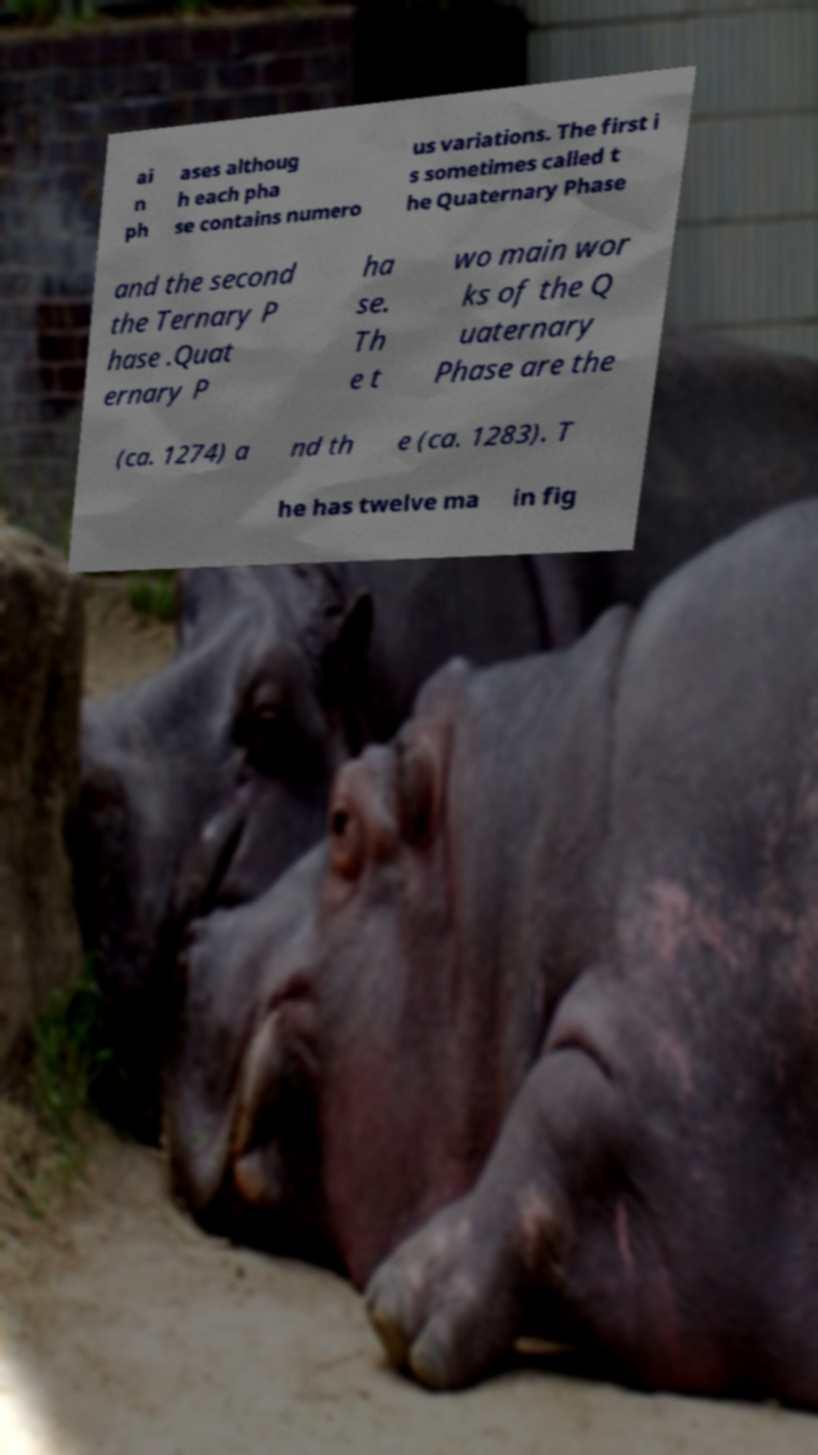There's text embedded in this image that I need extracted. Can you transcribe it verbatim? ai n ph ases althoug h each pha se contains numero us variations. The first i s sometimes called t he Quaternary Phase and the second the Ternary P hase .Quat ernary P ha se. Th e t wo main wor ks of the Q uaternary Phase are the (ca. 1274) a nd th e (ca. 1283). T he has twelve ma in fig 